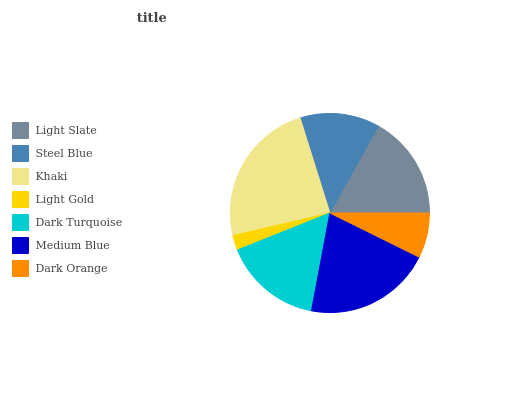Is Light Gold the minimum?
Answer yes or no. Yes. Is Khaki the maximum?
Answer yes or no. Yes. Is Steel Blue the minimum?
Answer yes or no. No. Is Steel Blue the maximum?
Answer yes or no. No. Is Light Slate greater than Steel Blue?
Answer yes or no. Yes. Is Steel Blue less than Light Slate?
Answer yes or no. Yes. Is Steel Blue greater than Light Slate?
Answer yes or no. No. Is Light Slate less than Steel Blue?
Answer yes or no. No. Is Dark Turquoise the high median?
Answer yes or no. Yes. Is Dark Turquoise the low median?
Answer yes or no. Yes. Is Light Gold the high median?
Answer yes or no. No. Is Khaki the low median?
Answer yes or no. No. 